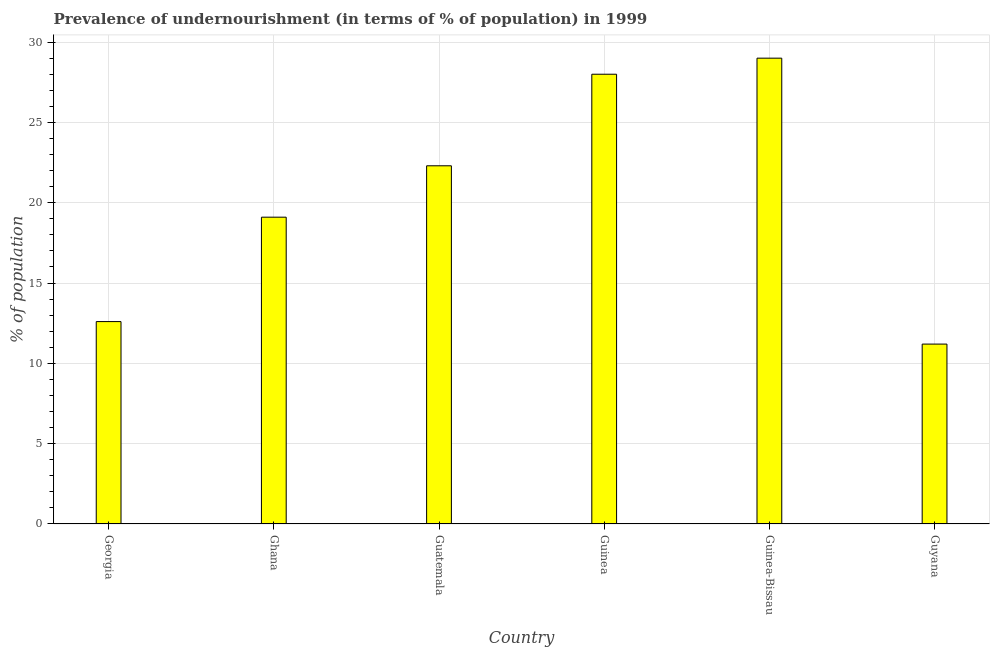What is the title of the graph?
Your answer should be compact. Prevalence of undernourishment (in terms of % of population) in 1999. What is the label or title of the X-axis?
Give a very brief answer. Country. What is the label or title of the Y-axis?
Give a very brief answer. % of population. What is the percentage of undernourished population in Guatemala?
Your answer should be very brief. 22.3. In which country was the percentage of undernourished population maximum?
Offer a very short reply. Guinea-Bissau. In which country was the percentage of undernourished population minimum?
Your answer should be very brief. Guyana. What is the sum of the percentage of undernourished population?
Make the answer very short. 122.2. What is the average percentage of undernourished population per country?
Make the answer very short. 20.37. What is the median percentage of undernourished population?
Keep it short and to the point. 20.7. What is the ratio of the percentage of undernourished population in Georgia to that in Guatemala?
Ensure brevity in your answer.  0.56. Is the percentage of undernourished population in Guinea less than that in Guinea-Bissau?
Provide a short and direct response. Yes. Is the sum of the percentage of undernourished population in Ghana and Guatemala greater than the maximum percentage of undernourished population across all countries?
Provide a succinct answer. Yes. In how many countries, is the percentage of undernourished population greater than the average percentage of undernourished population taken over all countries?
Make the answer very short. 3. How many bars are there?
Provide a succinct answer. 6. How many countries are there in the graph?
Give a very brief answer. 6. What is the % of population in Guatemala?
Provide a short and direct response. 22.3. What is the % of population of Guinea-Bissau?
Keep it short and to the point. 29. What is the difference between the % of population in Georgia and Ghana?
Give a very brief answer. -6.5. What is the difference between the % of population in Georgia and Guatemala?
Offer a terse response. -9.7. What is the difference between the % of population in Georgia and Guinea?
Offer a terse response. -15.4. What is the difference between the % of population in Georgia and Guinea-Bissau?
Make the answer very short. -16.4. What is the difference between the % of population in Georgia and Guyana?
Provide a succinct answer. 1.4. What is the difference between the % of population in Ghana and Guatemala?
Make the answer very short. -3.2. What is the difference between the % of population in Ghana and Guinea?
Your answer should be compact. -8.9. What is the difference between the % of population in Ghana and Guinea-Bissau?
Keep it short and to the point. -9.9. What is the difference between the % of population in Guatemala and Guinea?
Provide a short and direct response. -5.7. What is the difference between the % of population in Guatemala and Guinea-Bissau?
Give a very brief answer. -6.7. What is the difference between the % of population in Guinea and Guinea-Bissau?
Your answer should be very brief. -1. What is the difference between the % of population in Guinea and Guyana?
Provide a short and direct response. 16.8. What is the ratio of the % of population in Georgia to that in Ghana?
Your answer should be very brief. 0.66. What is the ratio of the % of population in Georgia to that in Guatemala?
Keep it short and to the point. 0.56. What is the ratio of the % of population in Georgia to that in Guinea?
Provide a succinct answer. 0.45. What is the ratio of the % of population in Georgia to that in Guinea-Bissau?
Provide a short and direct response. 0.43. What is the ratio of the % of population in Ghana to that in Guatemala?
Provide a short and direct response. 0.86. What is the ratio of the % of population in Ghana to that in Guinea?
Ensure brevity in your answer.  0.68. What is the ratio of the % of population in Ghana to that in Guinea-Bissau?
Make the answer very short. 0.66. What is the ratio of the % of population in Ghana to that in Guyana?
Keep it short and to the point. 1.71. What is the ratio of the % of population in Guatemala to that in Guinea?
Provide a short and direct response. 0.8. What is the ratio of the % of population in Guatemala to that in Guinea-Bissau?
Your answer should be compact. 0.77. What is the ratio of the % of population in Guatemala to that in Guyana?
Keep it short and to the point. 1.99. What is the ratio of the % of population in Guinea to that in Guinea-Bissau?
Ensure brevity in your answer.  0.97. What is the ratio of the % of population in Guinea-Bissau to that in Guyana?
Offer a terse response. 2.59. 